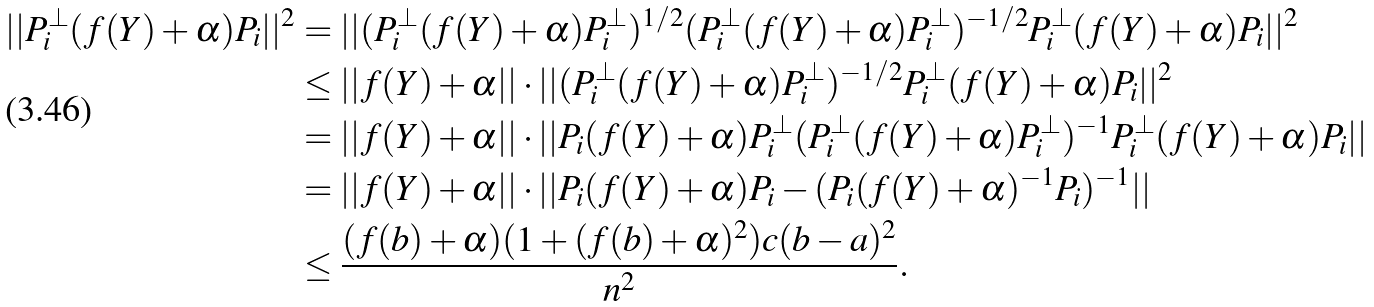<formula> <loc_0><loc_0><loc_500><loc_500>| | P _ { i } ^ { \perp } ( f ( Y ) + \alpha ) P _ { i } | | ^ { 2 } & = | | ( P _ { i } ^ { \perp } ( f ( Y ) + \alpha ) P _ { i } ^ { \perp } ) ^ { 1 / 2 } ( P _ { i } ^ { \perp } ( f ( Y ) + \alpha ) P _ { i } ^ { \perp } ) ^ { - 1 / 2 } P _ { i } ^ { \perp } ( f ( Y ) + \alpha ) P _ { i } | | ^ { 2 } \\ & \leq | | f ( Y ) + \alpha | | \cdot | | ( P _ { i } ^ { \perp } ( f ( Y ) + \alpha ) P _ { i } ^ { \perp } ) ^ { - 1 / 2 } P _ { i } ^ { \perp } ( f ( Y ) + \alpha ) P _ { i } | | ^ { 2 } \\ & = | | f ( Y ) + \alpha | | \cdot | | P _ { i } ( f ( Y ) + \alpha ) P _ { i } ^ { \perp } ( P _ { i } ^ { \perp } ( f ( Y ) + \alpha ) P _ { i } ^ { \perp } ) ^ { - 1 } P _ { i } ^ { \perp } ( f ( Y ) + \alpha ) P _ { i } | | \\ & = | | f ( Y ) + \alpha | | \cdot | | P _ { i } ( f ( Y ) + \alpha ) P _ { i } - ( P _ { i } ( f ( Y ) + \alpha ) ^ { - 1 } P _ { i } ) ^ { - 1 } | | \\ & \leq \frac { ( f ( b ) + \alpha ) ( 1 + ( f ( b ) + \alpha ) ^ { 2 } ) c ( b - a ) ^ { 2 } } { n ^ { 2 } } .</formula> 